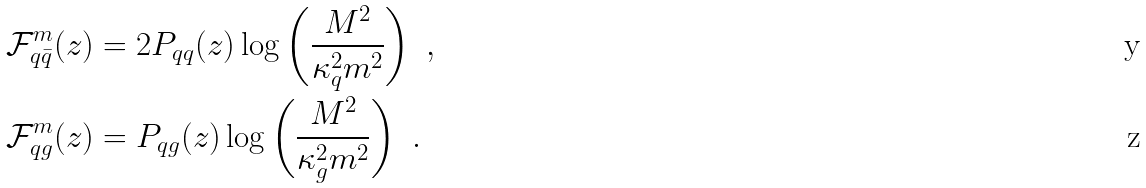<formula> <loc_0><loc_0><loc_500><loc_500>\mathcal { F } ^ { m } _ { q \bar { q } } ( z ) & = 2 P _ { q q } ( z ) \log \left ( \frac { M ^ { 2 } } { \kappa _ { q } ^ { 2 } m ^ { 2 } } \right ) \ , \\ \mathcal { F } ^ { m } _ { q g } ( z ) & = P _ { q g } ( z ) \log \left ( \frac { M ^ { 2 } } { \kappa _ { g } ^ { 2 } m ^ { 2 } } \right ) \ .</formula> 